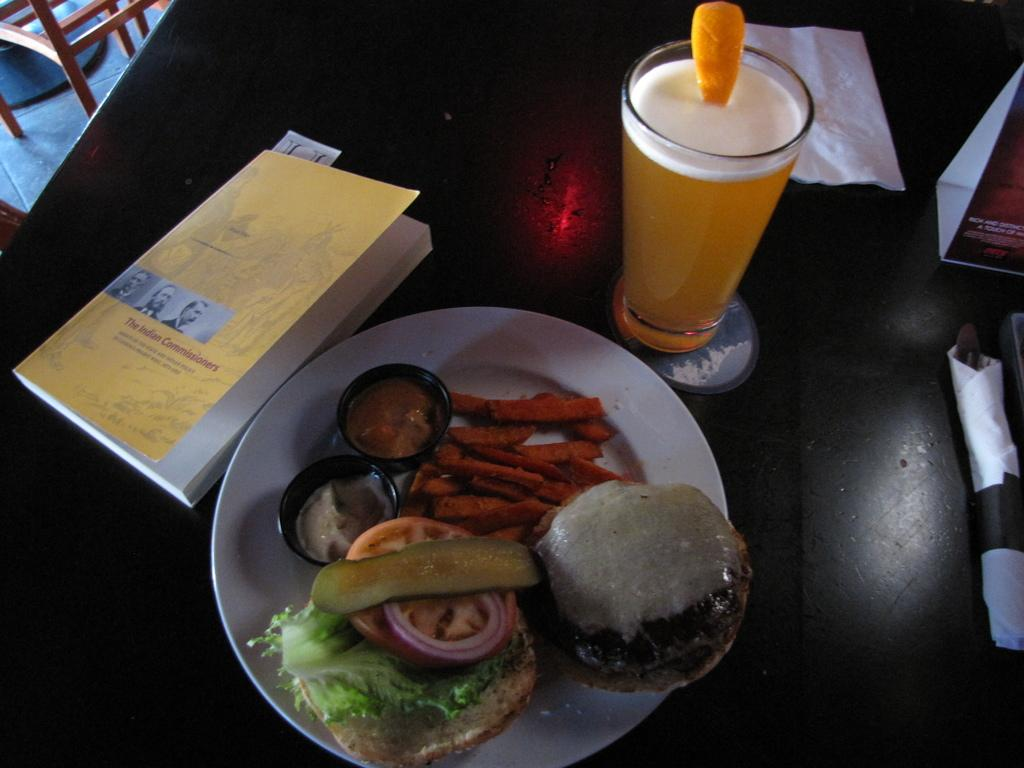What color is the table in the foreground of the image? The table in the foreground is black. What is placed on the black table? A book, a plate with food, a juice glass, and tissue paper are placed on the table. Can you describe any other objects on the table? There are additional objects on the table, but their specific details are not mentioned in the provided facts. How many plastic chairs are visible in the image? There is no mention of plastic chairs in the provided facts, so it cannot be determined from the image. 